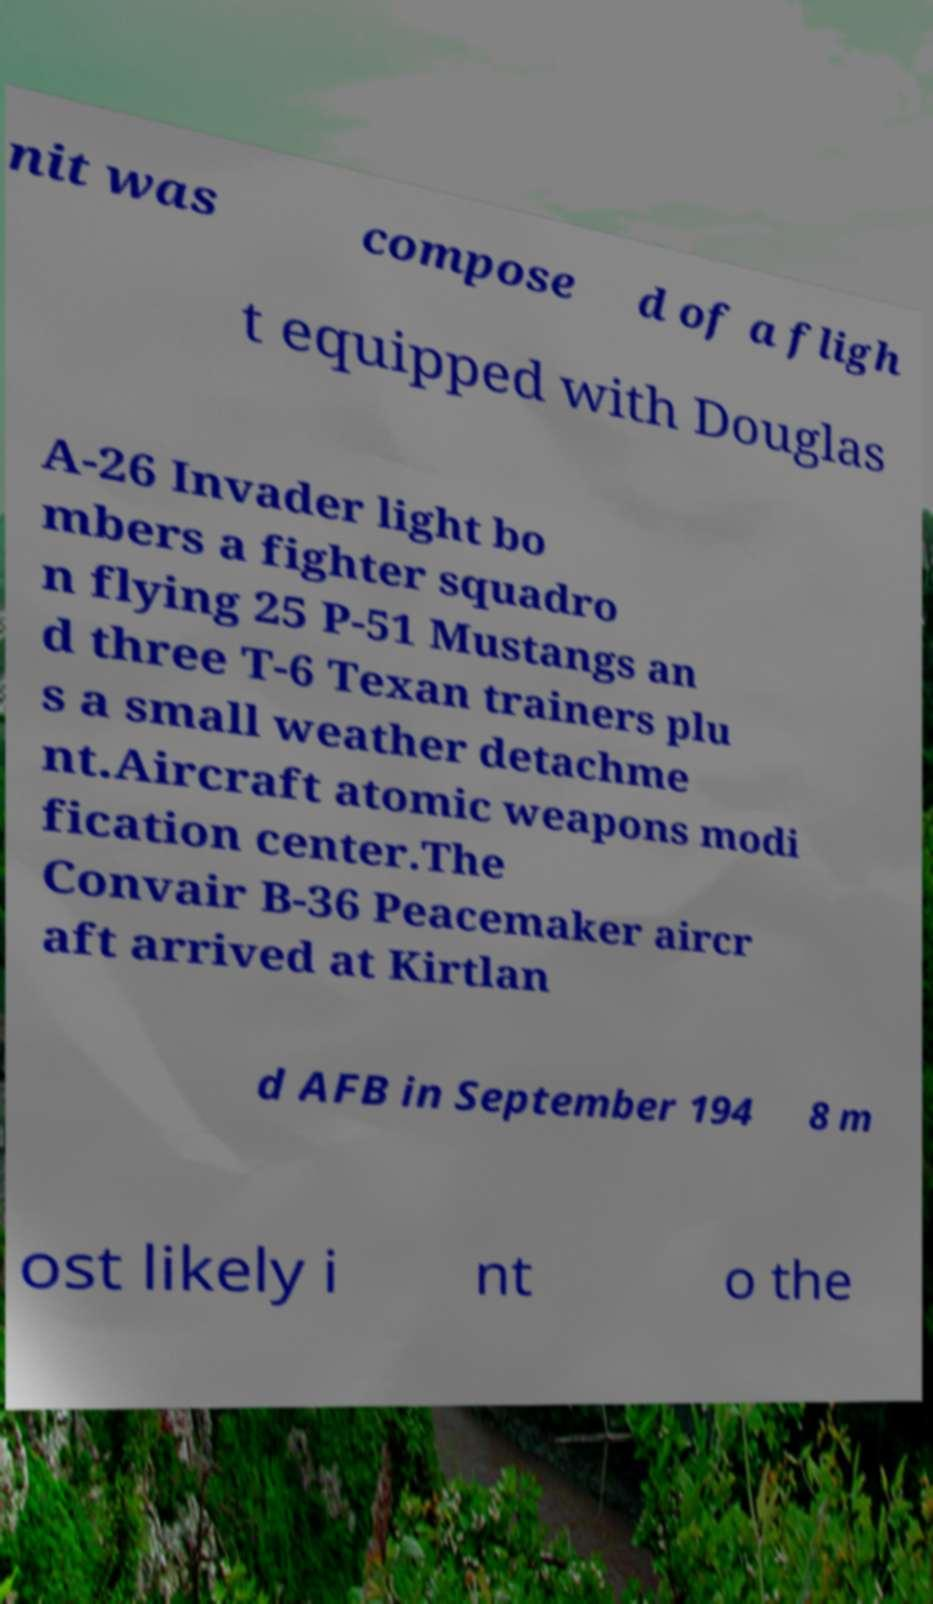Can you read and provide the text displayed in the image?This photo seems to have some interesting text. Can you extract and type it out for me? nit was compose d of a fligh t equipped with Douglas A-26 Invader light bo mbers a fighter squadro n flying 25 P-51 Mustangs an d three T-6 Texan trainers plu s a small weather detachme nt.Aircraft atomic weapons modi fication center.The Convair B-36 Peacemaker aircr aft arrived at Kirtlan d AFB in September 194 8 m ost likely i nt o the 